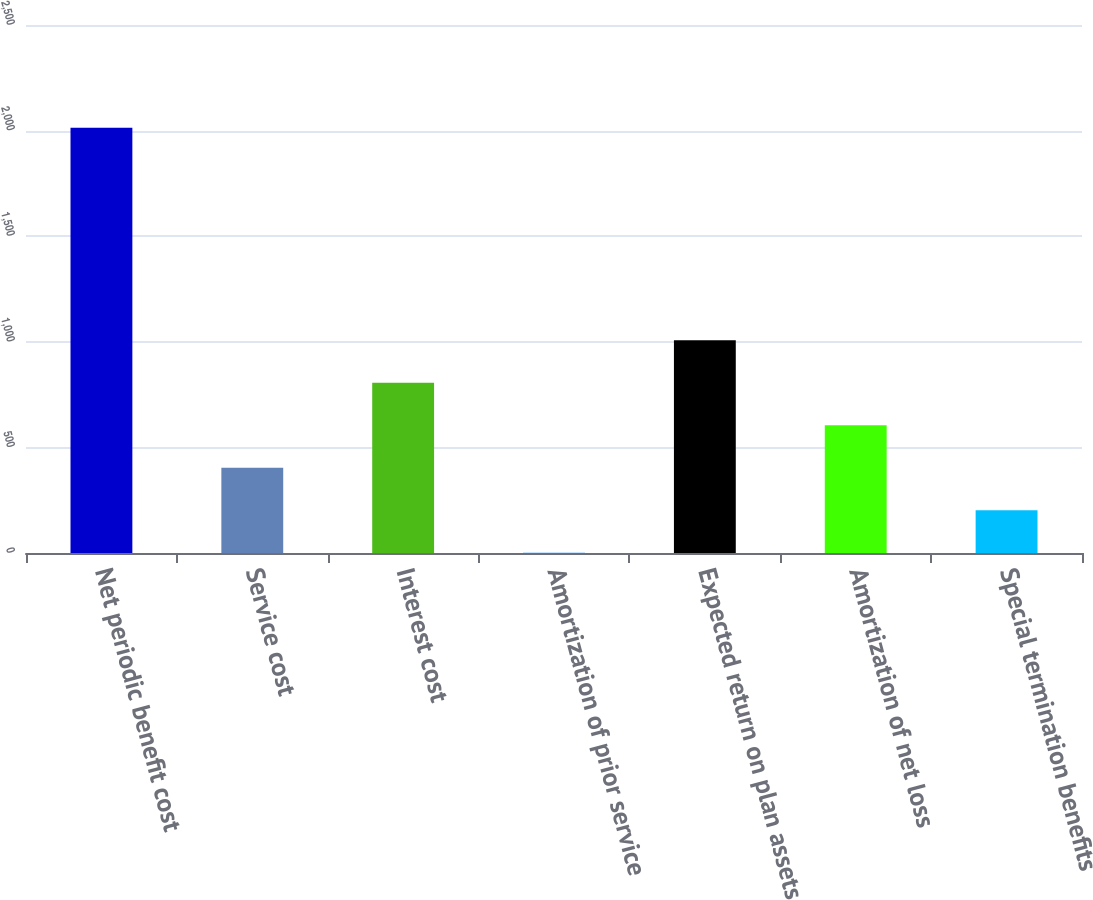<chart> <loc_0><loc_0><loc_500><loc_500><bar_chart><fcel>Net periodic benefit cost<fcel>Service cost<fcel>Interest cost<fcel>Amortization of prior service<fcel>Expected return on plan assets<fcel>Amortization of net loss<fcel>Special termination benefits<nl><fcel>2014<fcel>403.6<fcel>806.2<fcel>1<fcel>1007.5<fcel>604.9<fcel>202.3<nl></chart> 